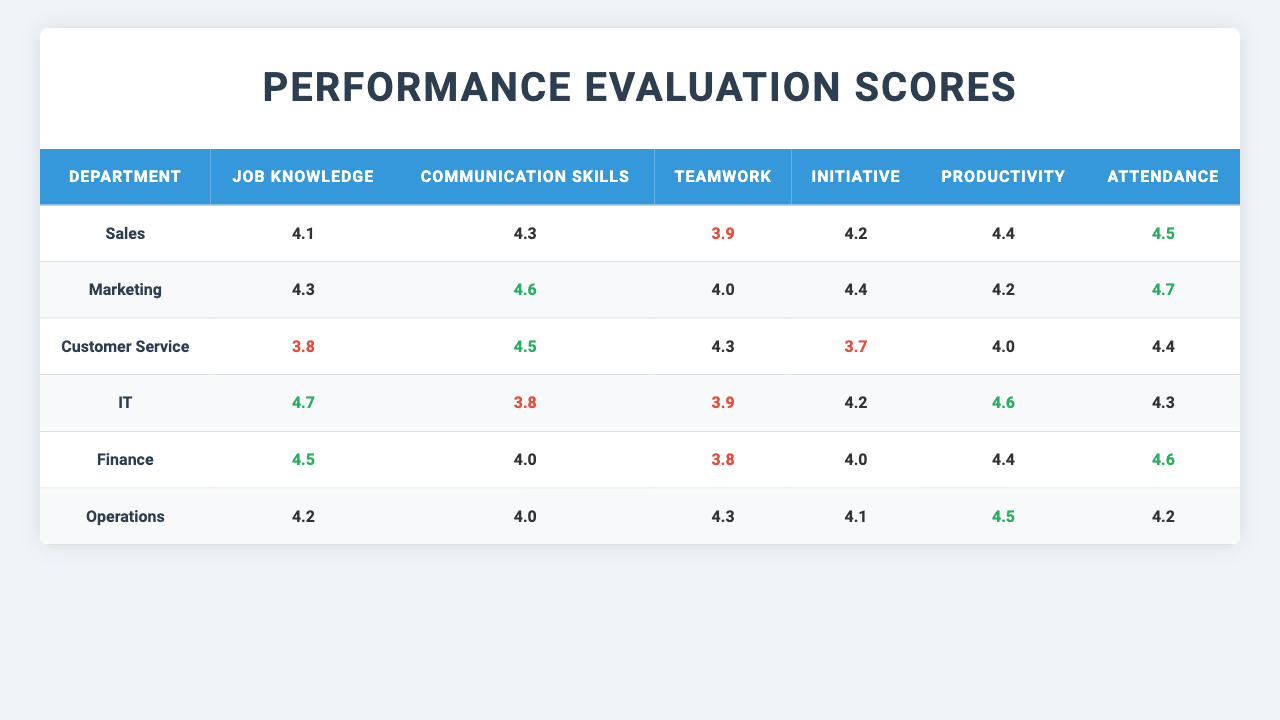What is the evaluation score for Job Knowledge in the IT department? The table shows that the score for Job Knowledge in the IT department is 4.8.
Answer: 4.8 Which department has the lowest average score for Teamwork? The average scores for Teamwork are: Sales (3.9), Marketing (4.0), Customer Service (4.3), IT (3.9), Finance (3.8), Operations (4.3). The lowest average score is 3.8 in the Finance department.
Answer: Finance What is the average score for Attendance across all departments? The Attendance scores are: Sales (4.5), Marketing (4.7), Customer Service (4.4), IT (4.3), Finance (4.6), Operations (4.2). To find the average: (4.5 + 4.7 + 4.4 + 4.3 + 4.6 + 4.2) / 6 = 4.45.
Answer: 4.45 Is there any department that scored above 4.5 in all evaluation criteria? By reviewing the scores, the Marketing department has scores above 4.5 for Job Knowledge (4.5), Communication Skills (4.8), Teamwork (4.2), Initiative (4.6), Productivity (4.4), and Attendance (4.9), indicating it has scored above 4.5 in all criteria.
Answer: Yes Which department has the highest average score for Initiative? The average scores for Initiative are: Sales (4.2), Marketing (4.4), Customer Service (3.7), IT (4.2), Finance (4.0), Operations (4.1). The highest average score for Initiative is in the Marketing department with a score of 4.4.
Answer: Marketing What is the difference in average scores for Communication Skills between Sales and Customer Service? The average score for Communication Skills in Sales is 4.3 and in Customer Service is 4.5. To find the difference: 4.5 - 4.3 = 0.2.
Answer: 0.2 Does any department have an average score under 4.0 for any evaluation criteria? Yes, the Finance department has the lowest average score for Teamwork at 3.8, which is under 4.0.
Answer: Yes Which department has the second highest average score for Productivity? Checking the scores: Sales (4.4), Marketing (4.2), Customer Service (4.0), IT (4.6), Finance (4.4), Operations (4.5). The highest is IT (4.6), and the second highest average score for Productivity is shared by Sales and Finance with a score of 4.4.
Answer: Sales and Finance What is the average Teamwork score across all departments? The Teamwork scores are: Sales (3.9), Marketing (4.0), Customer Service (4.3), IT (3.9), Finance (3.8), Operations (4.3). The average is calculated as (3.9 + 4.0 + 4.3 + 3.9 + 3.8 + 4.3) / 6 = 4.1.
Answer: 4.1 